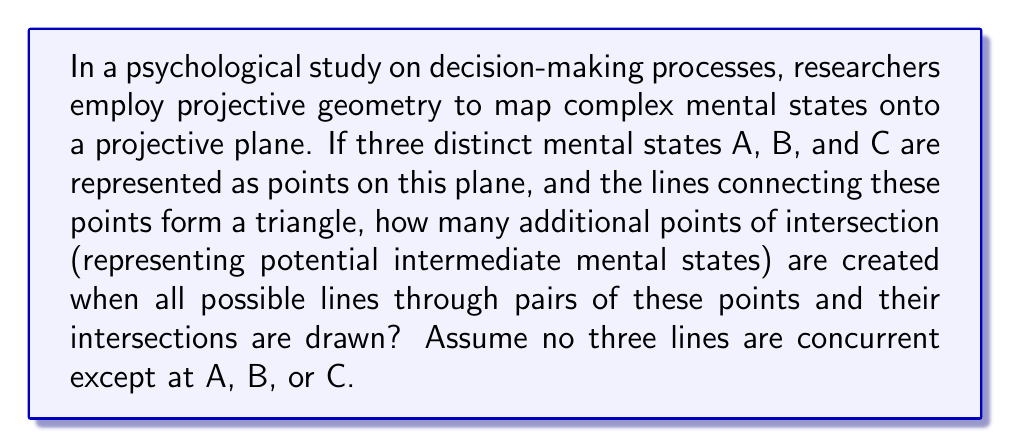Provide a solution to this math problem. Let's approach this step-by-step using concepts from projective geometry:

1) In projective geometry, any two distinct points determine a unique line. With points A, B, and C, we can draw three lines: AB, BC, and AC.

2) These three lines form a triangle in the projective plane.

3) Now, we need to consider all possible lines through pairs of intersection points. In projective geometry, this process is known as "completing the configuration."

4) Let's label the intersection points of these new lines:
   - AB intersects AC at point D (other than A)
   - BC intersects AC at point E (other than C)
   - AB intersects BC at point F (other than B)

5) Now we need to draw the line DE. This line will intersect AB at a new point, let's call it G.

6) Similarly, the line DF will intersect BC at a new point, call it H.

7) Finally, the line EF will intersect AC at a new point, call it I.

8) We have now completed the configuration, known as the complete quadrilateral or complete 4-point.

9) In total, we have added 6 new points of intersection: D, E, F, G, H, and I.

This configuration can be visualized as follows:

[asy]
import geometry;

pair A = (0,0), B = (100,0), C = (50,100);
pair D = extension(A,B,A,C);
pair E = extension(B,C,A,C);
pair F = extension(A,B,B,C);
pair G = extension(A,B,D,E);
pair H = extension(B,C,D,F);
pair I = extension(A,C,E,F);

draw(A--B--C--cycle);
draw(D--E);
draw(D--F);
draw(E--F);

dot("A",A,SW);
dot("B",B,SE);
dot("C",C,N);
dot("D",D,NW);
dot("E",E,NE);
dot("F",F,S);
dot("G",G,N);
dot("H",H,E);
dot("I",I,W);
[/asy]

Therefore, the projective geometry mapping of the three original mental states creates 6 additional points of intersection, representing potential intermediate mental states.
Answer: 6 points 